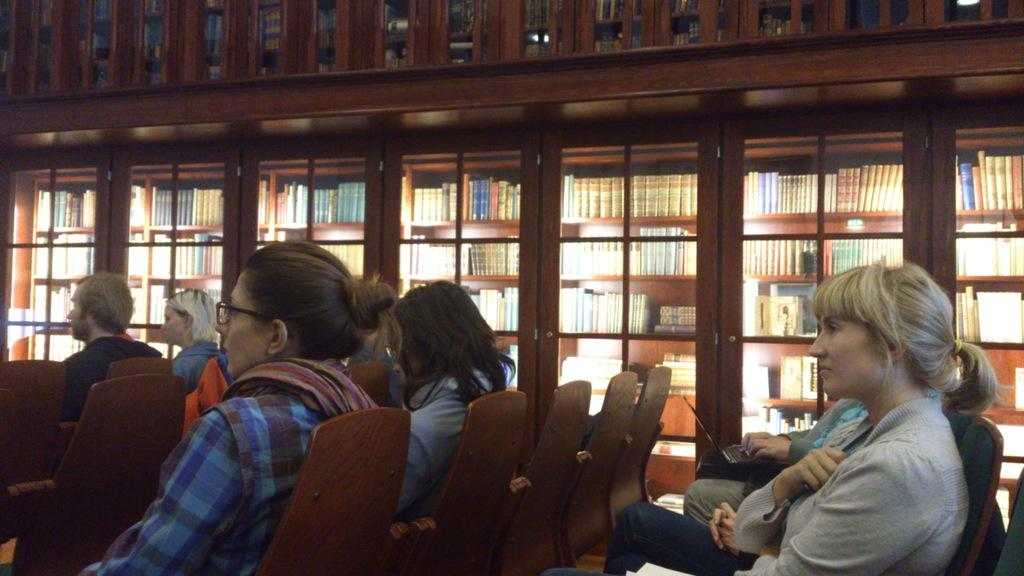What are the people in the image doing? The people in the image are sitting on chairs. What can be seen in the background of the image? There are racks in the background of the image. What is on the racks in the image? There are books on the racks in the image. Can you tell me where the trail is located in the image? There is no trail present in the image. What type of locket can be seen hanging from the books on the racks? There is no locket present in the image; it only features books on racks and people sitting on chairs. 